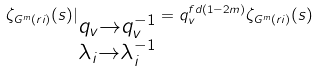<formula> <loc_0><loc_0><loc_500><loc_500>\zeta _ { G ^ { m } ( \L r i ) } ( s ) | _ { \substack { q _ { v } \rightarrow q _ { v } ^ { - 1 } \\ \lambda _ { i } \rightarrow \lambda _ { i } ^ { - 1 } } } = q _ { v } ^ { f d ( 1 - 2 m ) } \zeta _ { G ^ { m } ( \L r i ) } ( s )</formula> 